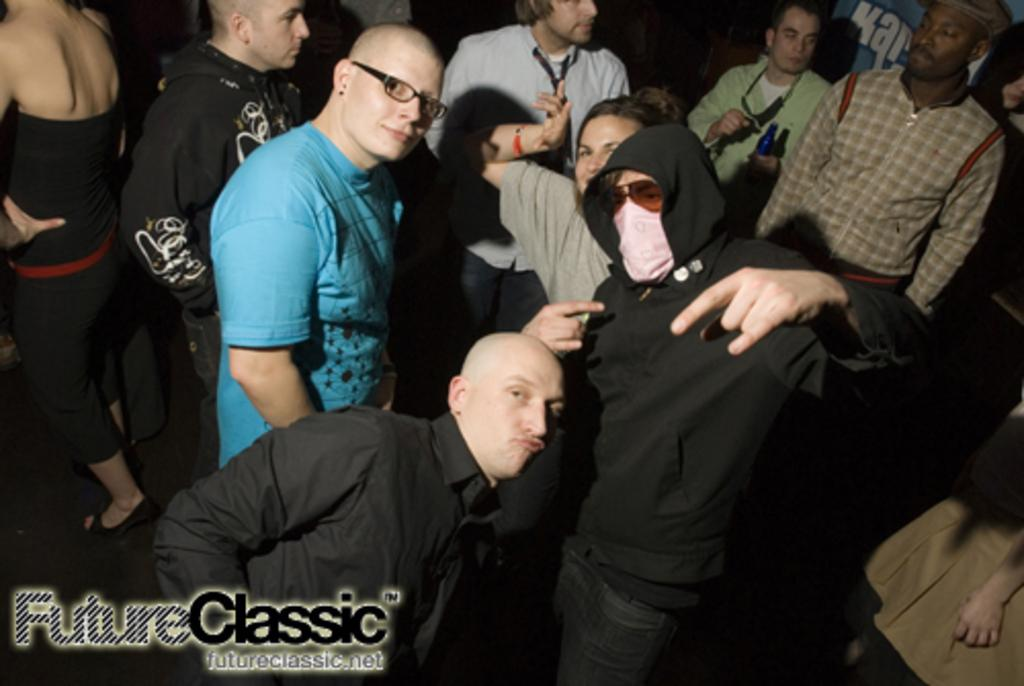Who or what can be seen in the image? There are people in the image. Can you describe any specific details about the people in the image? Some of the people in the image are wearing spectacles. Where is the lock located in the image? There is no lock present in the image. What type of sink can be seen in the image? There is no sink present in the image. 